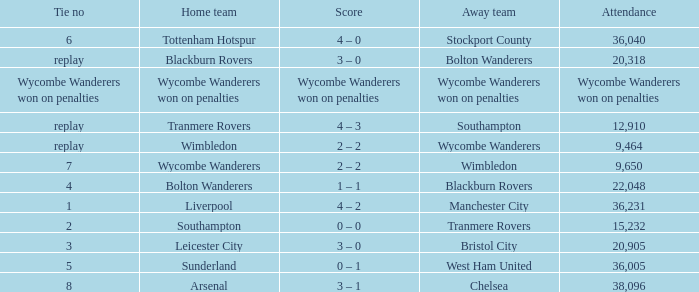What was the attendance for the game where the away team was Stockport County? 36040.0. Can you give me this table as a dict? {'header': ['Tie no', 'Home team', 'Score', 'Away team', 'Attendance'], 'rows': [['6', 'Tottenham Hotspur', '4 – 0', 'Stockport County', '36,040'], ['replay', 'Blackburn Rovers', '3 – 0', 'Bolton Wanderers', '20,318'], ['Wycombe Wanderers won on penalties', 'Wycombe Wanderers won on penalties', 'Wycombe Wanderers won on penalties', 'Wycombe Wanderers won on penalties', 'Wycombe Wanderers won on penalties'], ['replay', 'Tranmere Rovers', '4 – 3', 'Southampton', '12,910'], ['replay', 'Wimbledon', '2 – 2', 'Wycombe Wanderers', '9,464'], ['7', 'Wycombe Wanderers', '2 – 2', 'Wimbledon', '9,650'], ['4', 'Bolton Wanderers', '1 – 1', 'Blackburn Rovers', '22,048'], ['1', 'Liverpool', '4 – 2', 'Manchester City', '36,231'], ['2', 'Southampton', '0 – 0', 'Tranmere Rovers', '15,232'], ['3', 'Leicester City', '3 – 0', 'Bristol City', '20,905'], ['5', 'Sunderland', '0 – 1', 'West Ham United', '36,005'], ['8', 'Arsenal', '3 – 1', 'Chelsea', '38,096']]} 